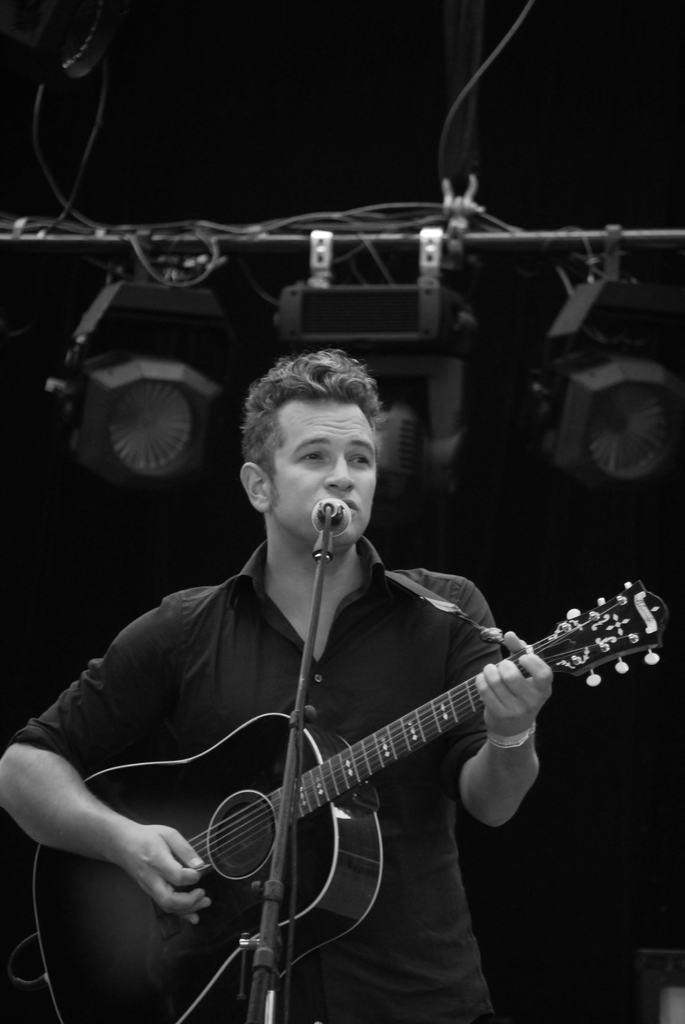Please provide a concise description of this image. A man is playing guitar and singing on the microphone. Behind him there is a pole with hanging lights. 